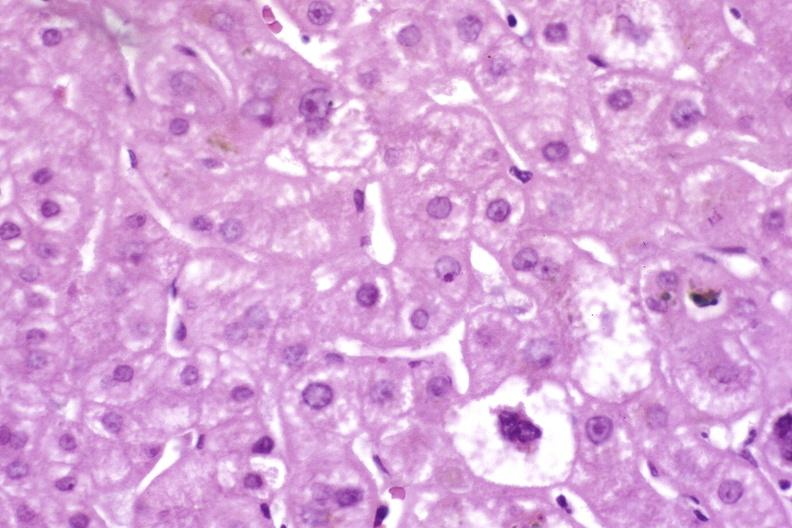s cat present?
Answer the question using a single word or phrase. No 